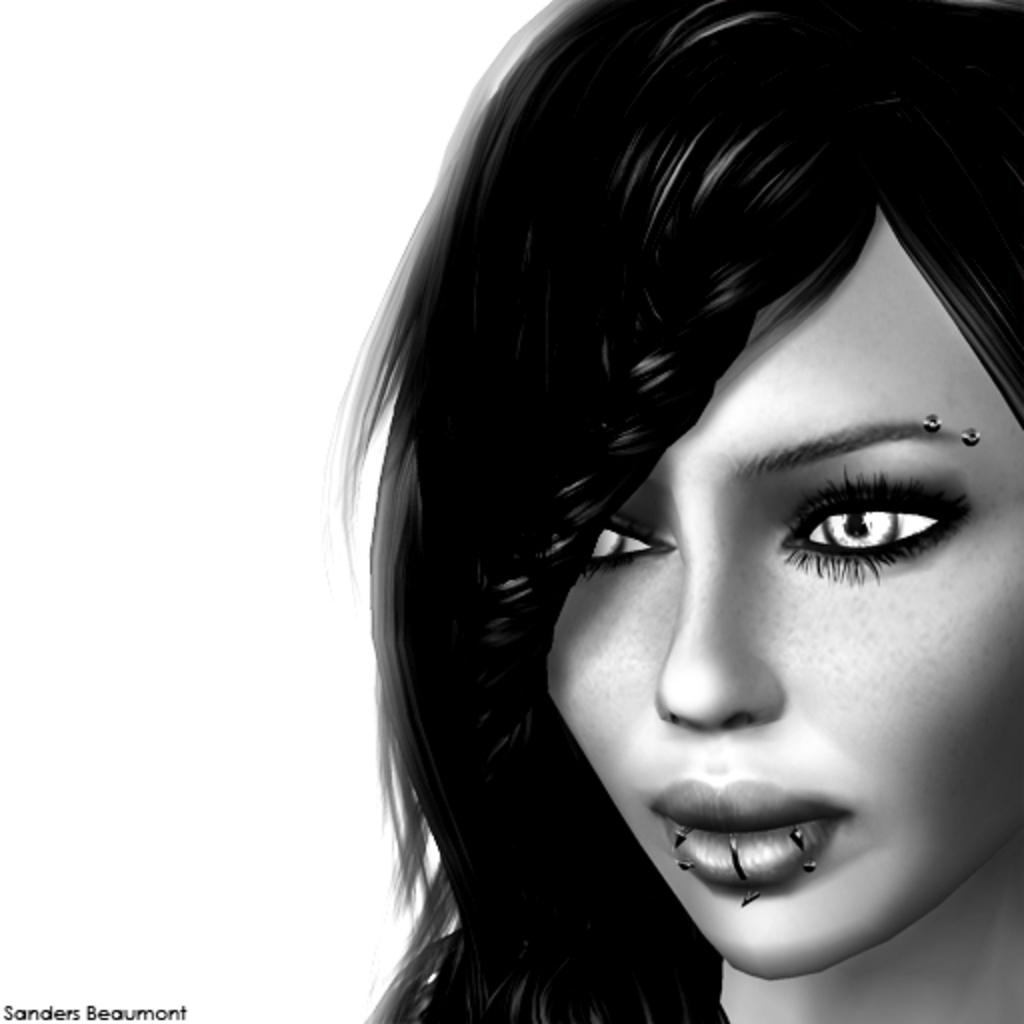What is the main subject of the image? There is a depiction of a woman in the image. Can you describe any additional features of the image? There is a watermark on the bottom left side of the image. What color scheme is used in the image? The image is black and white in color. What type of lock is used to secure the woman in the image? There is no lock present in the image; it is a depiction of a woman without any restraints. How much debt does the woman owe in the image? There is no indication of debt in the image; it is a depiction of a woman without any financial context. 